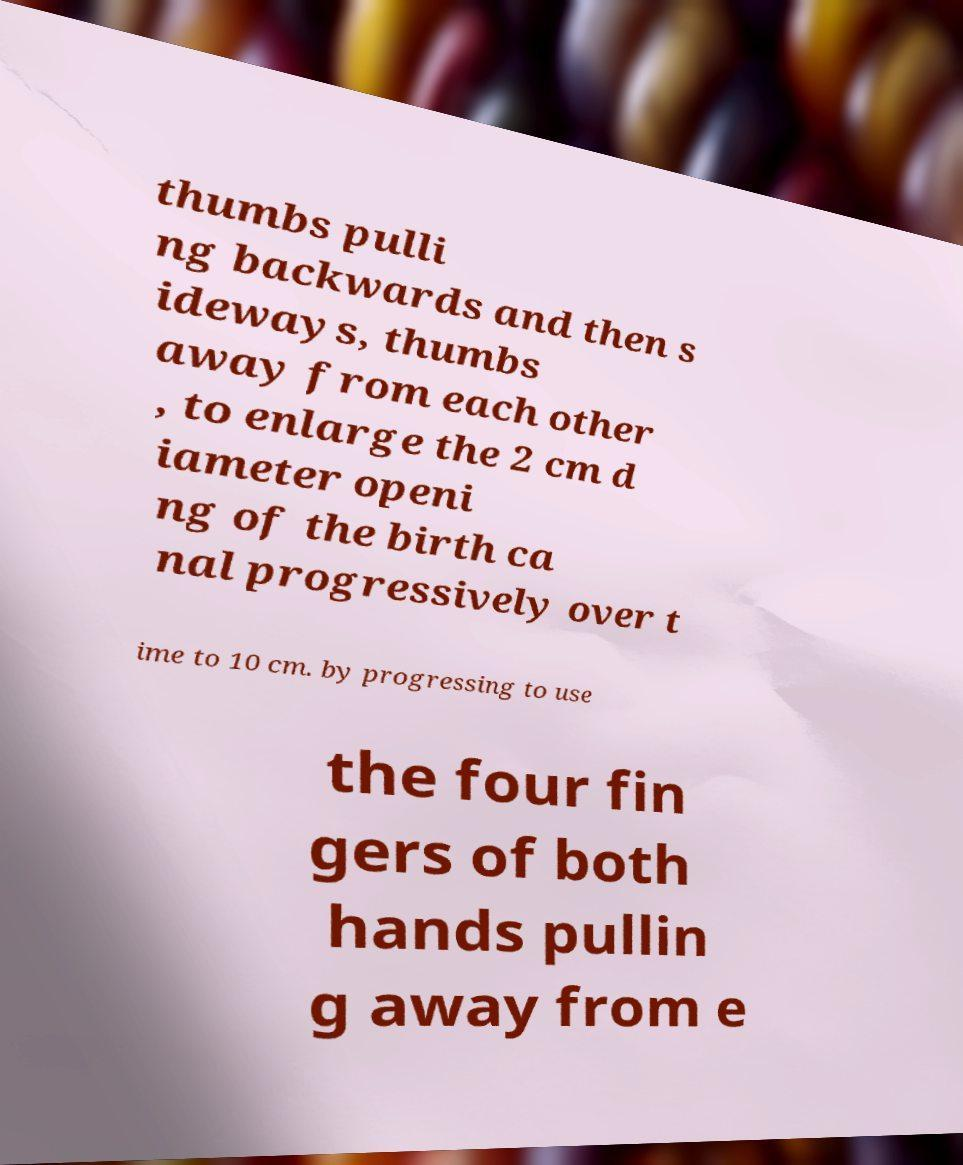Please read and relay the text visible in this image. What does it say? thumbs pulli ng backwards and then s ideways, thumbs away from each other , to enlarge the 2 cm d iameter openi ng of the birth ca nal progressively over t ime to 10 cm. by progressing to use the four fin gers of both hands pullin g away from e 